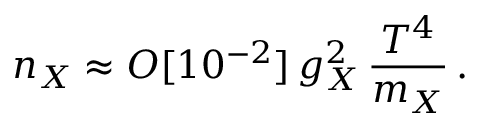Convert formula to latex. <formula><loc_0><loc_0><loc_500><loc_500>n _ { X } \approx O [ 1 0 ^ { - 2 } ] \, g _ { X } ^ { 2 } \, \frac { T ^ { 4 } } { m _ { X } } \, .</formula> 